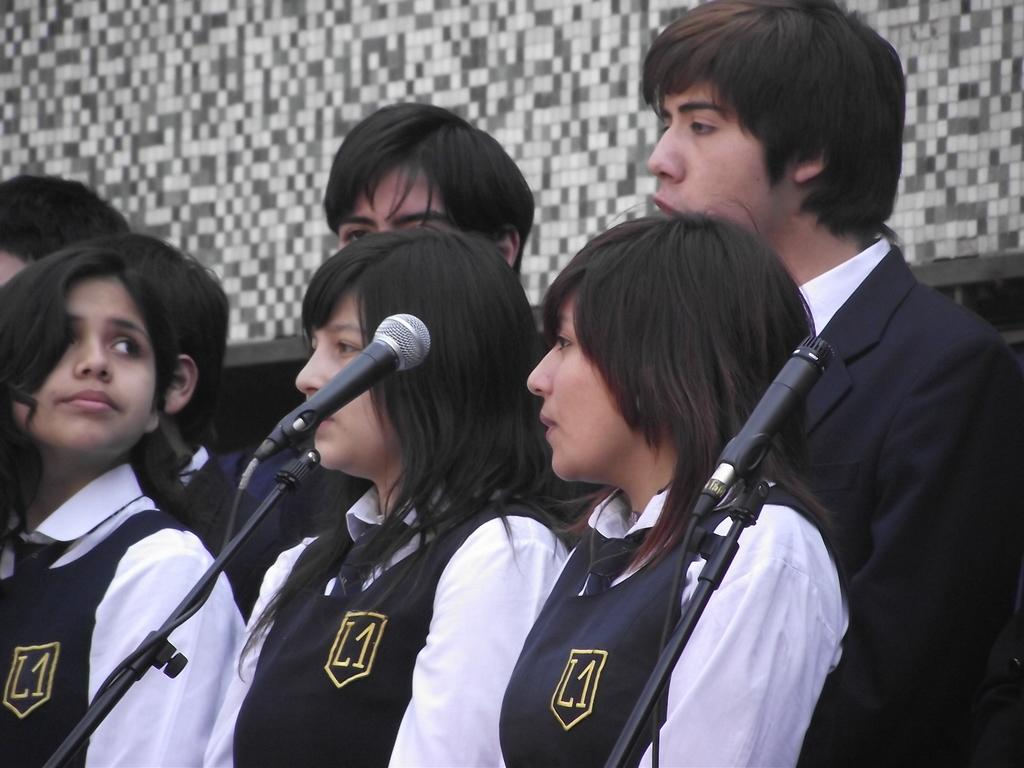How many persons can be seen in the image? There are a few persons in the image. What objects are visible in the image that might be related to the persons? There are microphones visible in the image. What can be seen in the background of the image? There is a wall in the background of the image. What type of nail is being used by the persons in the image? There is no nail present in the image. What type of cable can be seen connecting the microphones in the image? There is no cable connecting the microphones visible in the image. What type of oven is being used by the persons in the image? There is no oven present in the image. 